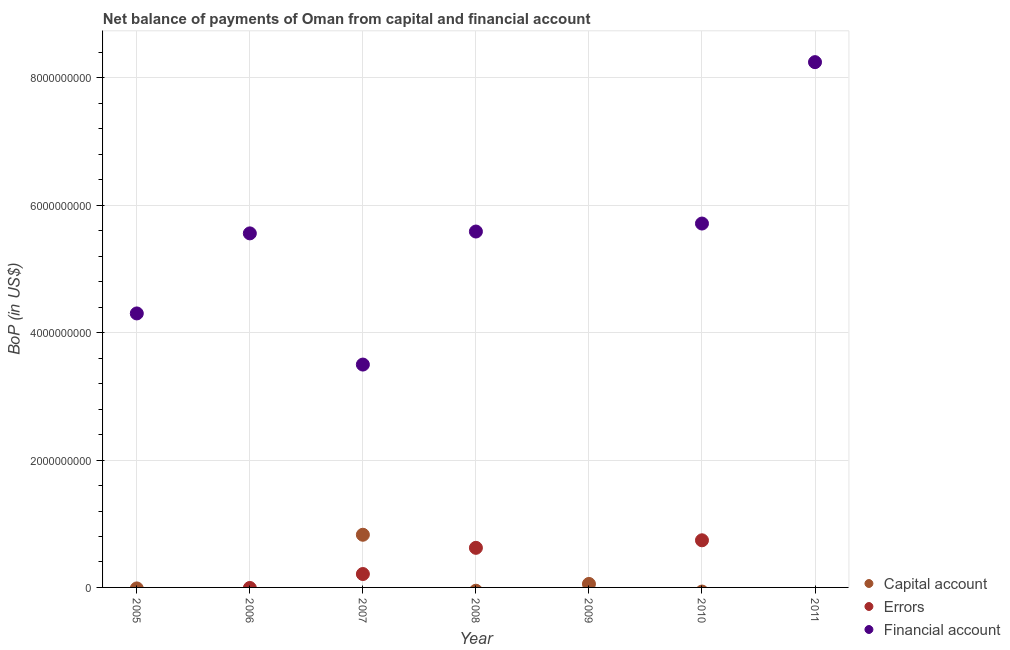How many different coloured dotlines are there?
Ensure brevity in your answer.  3. What is the amount of errors in 2006?
Ensure brevity in your answer.  0. Across all years, what is the maximum amount of errors?
Your answer should be compact. 7.40e+08. In which year was the amount of net capital account maximum?
Your answer should be compact. 2007. What is the total amount of financial account in the graph?
Ensure brevity in your answer.  3.29e+1. What is the difference between the amount of financial account in 2005 and that in 2006?
Offer a very short reply. -1.26e+09. What is the difference between the amount of net capital account in 2010 and the amount of financial account in 2009?
Your response must be concise. 0. What is the average amount of financial account per year?
Make the answer very short. 4.70e+09. In the year 2007, what is the difference between the amount of net capital account and amount of errors?
Offer a terse response. 6.17e+08. What is the ratio of the amount of financial account in 2006 to that in 2007?
Provide a succinct answer. 1.59. Is the amount of financial account in 2006 less than that in 2010?
Your answer should be compact. Yes. What is the difference between the highest and the second highest amount of errors?
Provide a short and direct response. 1.18e+08. What is the difference between the highest and the lowest amount of financial account?
Offer a very short reply. 8.25e+09. In how many years, is the amount of errors greater than the average amount of errors taken over all years?
Offer a very short reply. 2. Is it the case that in every year, the sum of the amount of net capital account and amount of errors is greater than the amount of financial account?
Give a very brief answer. No. Is the amount of net capital account strictly greater than the amount of errors over the years?
Provide a succinct answer. No. How many dotlines are there?
Your answer should be very brief. 3. How many years are there in the graph?
Your answer should be compact. 7. What is the difference between two consecutive major ticks on the Y-axis?
Provide a succinct answer. 2.00e+09. Are the values on the major ticks of Y-axis written in scientific E-notation?
Ensure brevity in your answer.  No. Where does the legend appear in the graph?
Your answer should be compact. Bottom right. How many legend labels are there?
Offer a terse response. 3. How are the legend labels stacked?
Your response must be concise. Vertical. What is the title of the graph?
Ensure brevity in your answer.  Net balance of payments of Oman from capital and financial account. What is the label or title of the Y-axis?
Your response must be concise. BoP (in US$). What is the BoP (in US$) of Capital account in 2005?
Provide a succinct answer. 0. What is the BoP (in US$) of Financial account in 2005?
Your response must be concise. 4.30e+09. What is the BoP (in US$) in Errors in 2006?
Offer a very short reply. 0. What is the BoP (in US$) of Financial account in 2006?
Provide a short and direct response. 5.56e+09. What is the BoP (in US$) in Capital account in 2007?
Make the answer very short. 8.27e+08. What is the BoP (in US$) of Errors in 2007?
Provide a succinct answer. 2.10e+08. What is the BoP (in US$) of Financial account in 2007?
Offer a very short reply. 3.50e+09. What is the BoP (in US$) in Errors in 2008?
Provide a short and direct response. 6.22e+08. What is the BoP (in US$) in Financial account in 2008?
Provide a short and direct response. 5.59e+09. What is the BoP (in US$) in Capital account in 2009?
Keep it short and to the point. 5.46e+07. What is the BoP (in US$) of Financial account in 2009?
Give a very brief answer. 0. What is the BoP (in US$) of Errors in 2010?
Your answer should be very brief. 7.40e+08. What is the BoP (in US$) of Financial account in 2010?
Your answer should be compact. 5.71e+09. What is the BoP (in US$) of Errors in 2011?
Offer a very short reply. 0. What is the BoP (in US$) in Financial account in 2011?
Give a very brief answer. 8.25e+09. Across all years, what is the maximum BoP (in US$) of Capital account?
Provide a short and direct response. 8.27e+08. Across all years, what is the maximum BoP (in US$) in Errors?
Give a very brief answer. 7.40e+08. Across all years, what is the maximum BoP (in US$) in Financial account?
Your answer should be compact. 8.25e+09. Across all years, what is the minimum BoP (in US$) in Errors?
Provide a short and direct response. 0. Across all years, what is the minimum BoP (in US$) of Financial account?
Your response must be concise. 0. What is the total BoP (in US$) of Capital account in the graph?
Offer a terse response. 8.82e+08. What is the total BoP (in US$) in Errors in the graph?
Offer a terse response. 1.57e+09. What is the total BoP (in US$) in Financial account in the graph?
Provide a succinct answer. 3.29e+1. What is the difference between the BoP (in US$) of Financial account in 2005 and that in 2006?
Offer a very short reply. -1.26e+09. What is the difference between the BoP (in US$) of Financial account in 2005 and that in 2007?
Provide a succinct answer. 8.03e+08. What is the difference between the BoP (in US$) of Financial account in 2005 and that in 2008?
Your answer should be compact. -1.29e+09. What is the difference between the BoP (in US$) of Financial account in 2005 and that in 2010?
Your response must be concise. -1.41e+09. What is the difference between the BoP (in US$) of Financial account in 2005 and that in 2011?
Keep it short and to the point. -3.95e+09. What is the difference between the BoP (in US$) in Financial account in 2006 and that in 2007?
Provide a succinct answer. 2.06e+09. What is the difference between the BoP (in US$) of Financial account in 2006 and that in 2008?
Offer a terse response. -2.90e+07. What is the difference between the BoP (in US$) in Financial account in 2006 and that in 2010?
Provide a short and direct response. -1.54e+08. What is the difference between the BoP (in US$) of Financial account in 2006 and that in 2011?
Your response must be concise. -2.69e+09. What is the difference between the BoP (in US$) in Errors in 2007 and that in 2008?
Give a very brief answer. -4.11e+08. What is the difference between the BoP (in US$) of Financial account in 2007 and that in 2008?
Your answer should be very brief. -2.09e+09. What is the difference between the BoP (in US$) of Capital account in 2007 and that in 2009?
Keep it short and to the point. 7.72e+08. What is the difference between the BoP (in US$) in Errors in 2007 and that in 2010?
Your response must be concise. -5.30e+08. What is the difference between the BoP (in US$) in Financial account in 2007 and that in 2010?
Your response must be concise. -2.21e+09. What is the difference between the BoP (in US$) of Financial account in 2007 and that in 2011?
Give a very brief answer. -4.75e+09. What is the difference between the BoP (in US$) of Errors in 2008 and that in 2010?
Keep it short and to the point. -1.18e+08. What is the difference between the BoP (in US$) in Financial account in 2008 and that in 2010?
Ensure brevity in your answer.  -1.26e+08. What is the difference between the BoP (in US$) of Financial account in 2008 and that in 2011?
Provide a succinct answer. -2.66e+09. What is the difference between the BoP (in US$) of Financial account in 2010 and that in 2011?
Provide a short and direct response. -2.53e+09. What is the difference between the BoP (in US$) in Capital account in 2007 and the BoP (in US$) in Errors in 2008?
Make the answer very short. 2.05e+08. What is the difference between the BoP (in US$) of Capital account in 2007 and the BoP (in US$) of Financial account in 2008?
Your response must be concise. -4.76e+09. What is the difference between the BoP (in US$) of Errors in 2007 and the BoP (in US$) of Financial account in 2008?
Give a very brief answer. -5.38e+09. What is the difference between the BoP (in US$) of Capital account in 2007 and the BoP (in US$) of Errors in 2010?
Your answer should be compact. 8.69e+07. What is the difference between the BoP (in US$) in Capital account in 2007 and the BoP (in US$) in Financial account in 2010?
Your answer should be very brief. -4.89e+09. What is the difference between the BoP (in US$) of Errors in 2007 and the BoP (in US$) of Financial account in 2010?
Provide a short and direct response. -5.50e+09. What is the difference between the BoP (in US$) of Capital account in 2007 and the BoP (in US$) of Financial account in 2011?
Provide a succinct answer. -7.42e+09. What is the difference between the BoP (in US$) of Errors in 2007 and the BoP (in US$) of Financial account in 2011?
Give a very brief answer. -8.04e+09. What is the difference between the BoP (in US$) of Errors in 2008 and the BoP (in US$) of Financial account in 2010?
Make the answer very short. -5.09e+09. What is the difference between the BoP (in US$) in Errors in 2008 and the BoP (in US$) in Financial account in 2011?
Keep it short and to the point. -7.63e+09. What is the difference between the BoP (in US$) in Capital account in 2009 and the BoP (in US$) in Errors in 2010?
Provide a short and direct response. -6.85e+08. What is the difference between the BoP (in US$) of Capital account in 2009 and the BoP (in US$) of Financial account in 2010?
Give a very brief answer. -5.66e+09. What is the difference between the BoP (in US$) of Capital account in 2009 and the BoP (in US$) of Financial account in 2011?
Offer a terse response. -8.19e+09. What is the difference between the BoP (in US$) of Errors in 2010 and the BoP (in US$) of Financial account in 2011?
Provide a succinct answer. -7.51e+09. What is the average BoP (in US$) in Capital account per year?
Your answer should be compact. 1.26e+08. What is the average BoP (in US$) in Errors per year?
Your answer should be very brief. 2.25e+08. What is the average BoP (in US$) of Financial account per year?
Offer a very short reply. 4.70e+09. In the year 2007, what is the difference between the BoP (in US$) of Capital account and BoP (in US$) of Errors?
Your answer should be very brief. 6.17e+08. In the year 2007, what is the difference between the BoP (in US$) in Capital account and BoP (in US$) in Financial account?
Keep it short and to the point. -2.67e+09. In the year 2007, what is the difference between the BoP (in US$) of Errors and BoP (in US$) of Financial account?
Your response must be concise. -3.29e+09. In the year 2008, what is the difference between the BoP (in US$) of Errors and BoP (in US$) of Financial account?
Offer a terse response. -4.97e+09. In the year 2010, what is the difference between the BoP (in US$) of Errors and BoP (in US$) of Financial account?
Your response must be concise. -4.97e+09. What is the ratio of the BoP (in US$) in Financial account in 2005 to that in 2006?
Your answer should be very brief. 0.77. What is the ratio of the BoP (in US$) in Financial account in 2005 to that in 2007?
Provide a succinct answer. 1.23. What is the ratio of the BoP (in US$) in Financial account in 2005 to that in 2008?
Make the answer very short. 0.77. What is the ratio of the BoP (in US$) of Financial account in 2005 to that in 2010?
Your answer should be compact. 0.75. What is the ratio of the BoP (in US$) of Financial account in 2005 to that in 2011?
Make the answer very short. 0.52. What is the ratio of the BoP (in US$) in Financial account in 2006 to that in 2007?
Provide a succinct answer. 1.59. What is the ratio of the BoP (in US$) of Financial account in 2006 to that in 2010?
Give a very brief answer. 0.97. What is the ratio of the BoP (in US$) of Financial account in 2006 to that in 2011?
Your answer should be very brief. 0.67. What is the ratio of the BoP (in US$) of Errors in 2007 to that in 2008?
Your answer should be compact. 0.34. What is the ratio of the BoP (in US$) in Financial account in 2007 to that in 2008?
Your answer should be very brief. 0.63. What is the ratio of the BoP (in US$) in Capital account in 2007 to that in 2009?
Ensure brevity in your answer.  15.14. What is the ratio of the BoP (in US$) in Errors in 2007 to that in 2010?
Give a very brief answer. 0.28. What is the ratio of the BoP (in US$) in Financial account in 2007 to that in 2010?
Your response must be concise. 0.61. What is the ratio of the BoP (in US$) in Financial account in 2007 to that in 2011?
Offer a very short reply. 0.42. What is the ratio of the BoP (in US$) of Errors in 2008 to that in 2010?
Offer a very short reply. 0.84. What is the ratio of the BoP (in US$) of Financial account in 2008 to that in 2011?
Make the answer very short. 0.68. What is the ratio of the BoP (in US$) in Financial account in 2010 to that in 2011?
Your answer should be very brief. 0.69. What is the difference between the highest and the second highest BoP (in US$) of Errors?
Provide a succinct answer. 1.18e+08. What is the difference between the highest and the second highest BoP (in US$) in Financial account?
Ensure brevity in your answer.  2.53e+09. What is the difference between the highest and the lowest BoP (in US$) in Capital account?
Ensure brevity in your answer.  8.27e+08. What is the difference between the highest and the lowest BoP (in US$) in Errors?
Give a very brief answer. 7.40e+08. What is the difference between the highest and the lowest BoP (in US$) in Financial account?
Your answer should be very brief. 8.25e+09. 